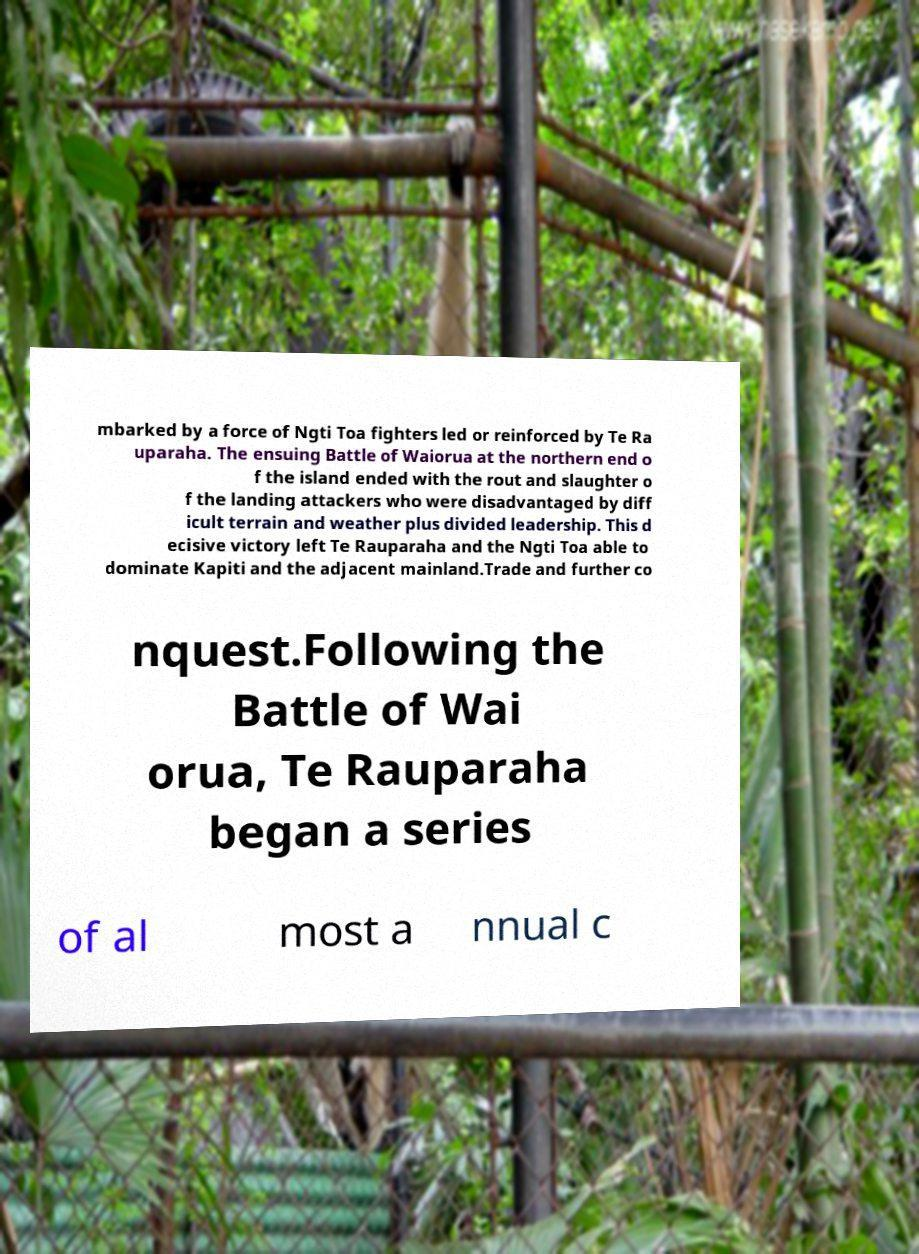For documentation purposes, I need the text within this image transcribed. Could you provide that? mbarked by a force of Ngti Toa fighters led or reinforced by Te Ra uparaha. The ensuing Battle of Waiorua at the northern end o f the island ended with the rout and slaughter o f the landing attackers who were disadvantaged by diff icult terrain and weather plus divided leadership. This d ecisive victory left Te Rauparaha and the Ngti Toa able to dominate Kapiti and the adjacent mainland.Trade and further co nquest.Following the Battle of Wai orua, Te Rauparaha began a series of al most a nnual c 